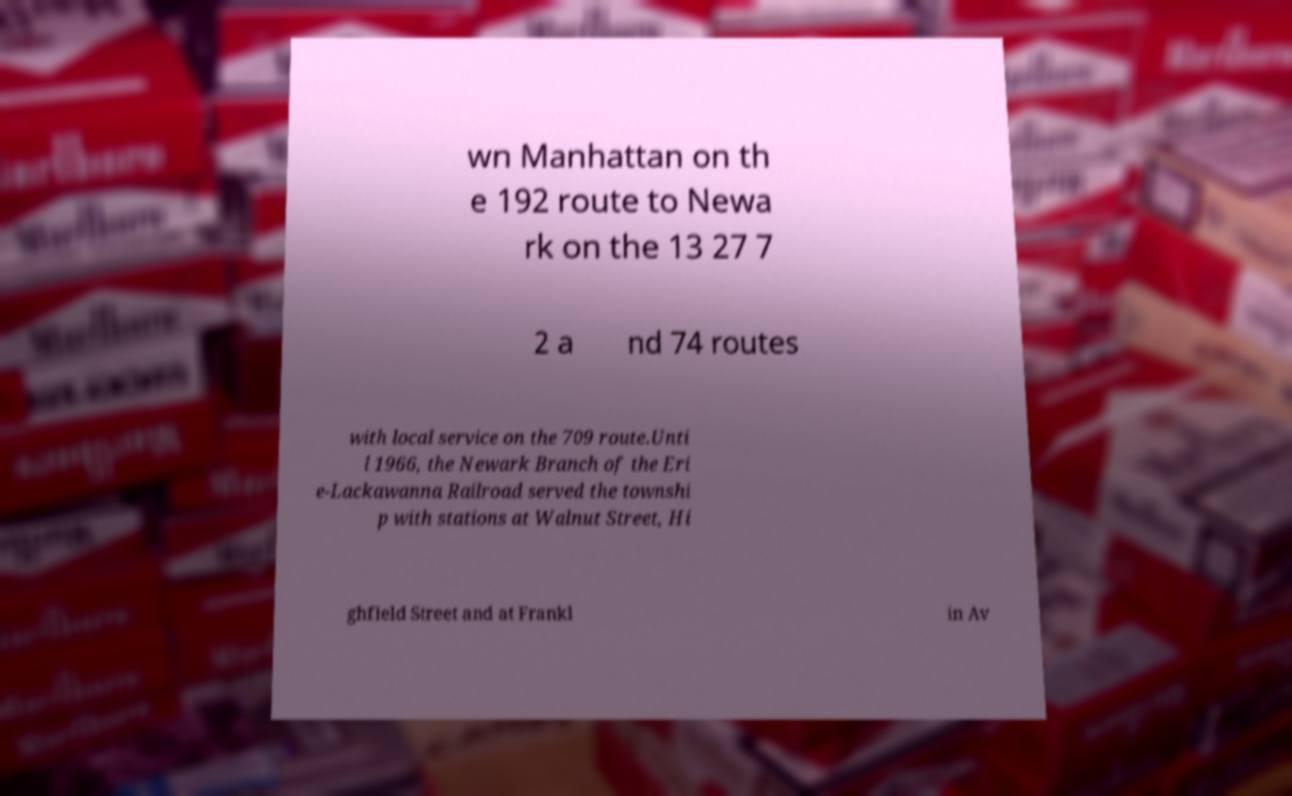Can you accurately transcribe the text from the provided image for me? wn Manhattan on th e 192 route to Newa rk on the 13 27 7 2 a nd 74 routes with local service on the 709 route.Unti l 1966, the Newark Branch of the Eri e-Lackawanna Railroad served the townshi p with stations at Walnut Street, Hi ghfield Street and at Frankl in Av 